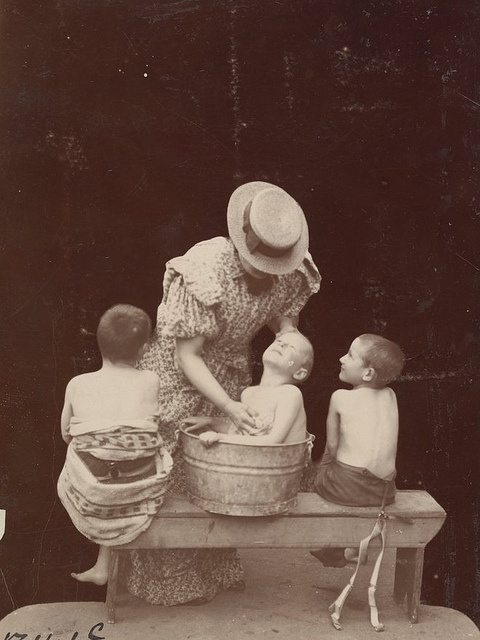Describe the objects in this image and their specific colors. I can see people in maroon, gray, and tan tones, people in maroon, tan, and gray tones, bench in maroon and gray tones, people in maroon, gray, tan, and darkgray tones, and people in maroon, tan, and gray tones in this image. 